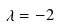Convert formula to latex. <formula><loc_0><loc_0><loc_500><loc_500>\lambda = - 2</formula> 